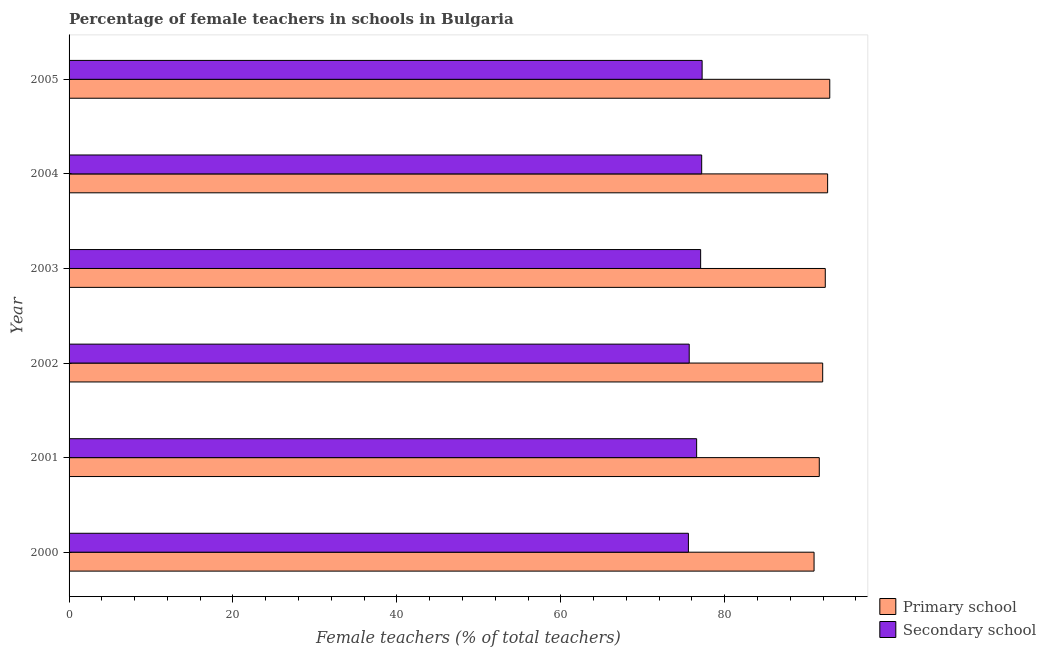How many different coloured bars are there?
Give a very brief answer. 2. How many bars are there on the 3rd tick from the top?
Give a very brief answer. 2. How many bars are there on the 4th tick from the bottom?
Offer a very short reply. 2. What is the percentage of female teachers in primary schools in 2000?
Your response must be concise. 90.91. Across all years, what is the maximum percentage of female teachers in primary schools?
Ensure brevity in your answer.  92.82. Across all years, what is the minimum percentage of female teachers in secondary schools?
Your answer should be compact. 75.57. In which year was the percentage of female teachers in secondary schools maximum?
Offer a very short reply. 2005. In which year was the percentage of female teachers in primary schools minimum?
Offer a terse response. 2000. What is the total percentage of female teachers in primary schools in the graph?
Make the answer very short. 552.06. What is the difference between the percentage of female teachers in secondary schools in 2002 and that in 2003?
Provide a succinct answer. -1.39. What is the difference between the percentage of female teachers in primary schools in 2000 and the percentage of female teachers in secondary schools in 2005?
Offer a terse response. 13.66. What is the average percentage of female teachers in secondary schools per year?
Give a very brief answer. 76.55. In the year 2005, what is the difference between the percentage of female teachers in secondary schools and percentage of female teachers in primary schools?
Offer a terse response. -15.57. In how many years, is the percentage of female teachers in secondary schools greater than 80 %?
Your response must be concise. 0. Is the percentage of female teachers in secondary schools in 2000 less than that in 2002?
Offer a very short reply. Yes. Is the difference between the percentage of female teachers in secondary schools in 2000 and 2003 greater than the difference between the percentage of female teachers in primary schools in 2000 and 2003?
Your answer should be compact. No. What is the difference between the highest and the second highest percentage of female teachers in primary schools?
Offer a terse response. 0.26. What is the difference between the highest and the lowest percentage of female teachers in secondary schools?
Offer a very short reply. 1.68. In how many years, is the percentage of female teachers in primary schools greater than the average percentage of female teachers in primary schools taken over all years?
Your response must be concise. 3. What does the 1st bar from the top in 2004 represents?
Provide a short and direct response. Secondary school. What does the 1st bar from the bottom in 2002 represents?
Offer a terse response. Primary school. How many bars are there?
Ensure brevity in your answer.  12. How many years are there in the graph?
Ensure brevity in your answer.  6. What is the difference between two consecutive major ticks on the X-axis?
Provide a succinct answer. 20. Are the values on the major ticks of X-axis written in scientific E-notation?
Keep it short and to the point. No. Does the graph contain any zero values?
Offer a terse response. No. Does the graph contain grids?
Provide a succinct answer. No. What is the title of the graph?
Give a very brief answer. Percentage of female teachers in schools in Bulgaria. What is the label or title of the X-axis?
Provide a short and direct response. Female teachers (% of total teachers). What is the label or title of the Y-axis?
Your answer should be compact. Year. What is the Female teachers (% of total teachers) in Primary school in 2000?
Offer a terse response. 90.91. What is the Female teachers (% of total teachers) of Secondary school in 2000?
Provide a succinct answer. 75.57. What is the Female teachers (% of total teachers) in Primary school in 2001?
Ensure brevity in your answer.  91.54. What is the Female teachers (% of total teachers) in Secondary school in 2001?
Your answer should be very brief. 76.58. What is the Female teachers (% of total teachers) in Primary school in 2002?
Ensure brevity in your answer.  91.96. What is the Female teachers (% of total teachers) of Secondary school in 2002?
Offer a terse response. 75.67. What is the Female teachers (% of total teachers) of Primary school in 2003?
Your response must be concise. 92.27. What is the Female teachers (% of total teachers) in Secondary school in 2003?
Keep it short and to the point. 77.06. What is the Female teachers (% of total teachers) of Primary school in 2004?
Offer a very short reply. 92.56. What is the Female teachers (% of total teachers) in Secondary school in 2004?
Make the answer very short. 77.19. What is the Female teachers (% of total teachers) in Primary school in 2005?
Provide a succinct answer. 92.82. What is the Female teachers (% of total teachers) of Secondary school in 2005?
Offer a terse response. 77.25. Across all years, what is the maximum Female teachers (% of total teachers) in Primary school?
Provide a short and direct response. 92.82. Across all years, what is the maximum Female teachers (% of total teachers) of Secondary school?
Offer a terse response. 77.25. Across all years, what is the minimum Female teachers (% of total teachers) of Primary school?
Provide a succinct answer. 90.91. Across all years, what is the minimum Female teachers (% of total teachers) of Secondary school?
Keep it short and to the point. 75.57. What is the total Female teachers (% of total teachers) in Primary school in the graph?
Provide a short and direct response. 552.06. What is the total Female teachers (% of total teachers) of Secondary school in the graph?
Your response must be concise. 459.32. What is the difference between the Female teachers (% of total teachers) of Primary school in 2000 and that in 2001?
Provide a short and direct response. -0.64. What is the difference between the Female teachers (% of total teachers) of Secondary school in 2000 and that in 2001?
Provide a succinct answer. -1.01. What is the difference between the Female teachers (% of total teachers) of Primary school in 2000 and that in 2002?
Make the answer very short. -1.05. What is the difference between the Female teachers (% of total teachers) of Secondary school in 2000 and that in 2002?
Your answer should be compact. -0.1. What is the difference between the Female teachers (% of total teachers) in Primary school in 2000 and that in 2003?
Offer a very short reply. -1.37. What is the difference between the Female teachers (% of total teachers) of Secondary school in 2000 and that in 2003?
Your response must be concise. -1.49. What is the difference between the Female teachers (% of total teachers) of Primary school in 2000 and that in 2004?
Keep it short and to the point. -1.65. What is the difference between the Female teachers (% of total teachers) in Secondary school in 2000 and that in 2004?
Provide a short and direct response. -1.62. What is the difference between the Female teachers (% of total teachers) of Primary school in 2000 and that in 2005?
Your answer should be very brief. -1.92. What is the difference between the Female teachers (% of total teachers) in Secondary school in 2000 and that in 2005?
Keep it short and to the point. -1.68. What is the difference between the Female teachers (% of total teachers) of Primary school in 2001 and that in 2002?
Your answer should be very brief. -0.42. What is the difference between the Female teachers (% of total teachers) of Secondary school in 2001 and that in 2002?
Offer a terse response. 0.91. What is the difference between the Female teachers (% of total teachers) in Primary school in 2001 and that in 2003?
Keep it short and to the point. -0.73. What is the difference between the Female teachers (% of total teachers) of Secondary school in 2001 and that in 2003?
Your response must be concise. -0.49. What is the difference between the Female teachers (% of total teachers) in Primary school in 2001 and that in 2004?
Ensure brevity in your answer.  -1.02. What is the difference between the Female teachers (% of total teachers) in Secondary school in 2001 and that in 2004?
Offer a terse response. -0.62. What is the difference between the Female teachers (% of total teachers) in Primary school in 2001 and that in 2005?
Provide a short and direct response. -1.28. What is the difference between the Female teachers (% of total teachers) in Secondary school in 2001 and that in 2005?
Provide a succinct answer. -0.67. What is the difference between the Female teachers (% of total teachers) in Primary school in 2002 and that in 2003?
Offer a very short reply. -0.32. What is the difference between the Female teachers (% of total teachers) in Secondary school in 2002 and that in 2003?
Keep it short and to the point. -1.39. What is the difference between the Female teachers (% of total teachers) of Primary school in 2002 and that in 2004?
Make the answer very short. -0.6. What is the difference between the Female teachers (% of total teachers) in Secondary school in 2002 and that in 2004?
Give a very brief answer. -1.52. What is the difference between the Female teachers (% of total teachers) in Primary school in 2002 and that in 2005?
Your response must be concise. -0.86. What is the difference between the Female teachers (% of total teachers) of Secondary school in 2002 and that in 2005?
Make the answer very short. -1.58. What is the difference between the Female teachers (% of total teachers) of Primary school in 2003 and that in 2004?
Your answer should be compact. -0.29. What is the difference between the Female teachers (% of total teachers) of Secondary school in 2003 and that in 2004?
Ensure brevity in your answer.  -0.13. What is the difference between the Female teachers (% of total teachers) of Primary school in 2003 and that in 2005?
Your answer should be compact. -0.55. What is the difference between the Female teachers (% of total teachers) in Secondary school in 2003 and that in 2005?
Provide a succinct answer. -0.18. What is the difference between the Female teachers (% of total teachers) of Primary school in 2004 and that in 2005?
Provide a succinct answer. -0.26. What is the difference between the Female teachers (% of total teachers) in Secondary school in 2004 and that in 2005?
Provide a short and direct response. -0.05. What is the difference between the Female teachers (% of total teachers) of Primary school in 2000 and the Female teachers (% of total teachers) of Secondary school in 2001?
Your answer should be compact. 14.33. What is the difference between the Female teachers (% of total teachers) in Primary school in 2000 and the Female teachers (% of total teachers) in Secondary school in 2002?
Offer a very short reply. 15.23. What is the difference between the Female teachers (% of total teachers) in Primary school in 2000 and the Female teachers (% of total teachers) in Secondary school in 2003?
Give a very brief answer. 13.84. What is the difference between the Female teachers (% of total teachers) in Primary school in 2000 and the Female teachers (% of total teachers) in Secondary school in 2004?
Keep it short and to the point. 13.71. What is the difference between the Female teachers (% of total teachers) in Primary school in 2000 and the Female teachers (% of total teachers) in Secondary school in 2005?
Offer a terse response. 13.66. What is the difference between the Female teachers (% of total teachers) in Primary school in 2001 and the Female teachers (% of total teachers) in Secondary school in 2002?
Offer a very short reply. 15.87. What is the difference between the Female teachers (% of total teachers) of Primary school in 2001 and the Female teachers (% of total teachers) of Secondary school in 2003?
Offer a very short reply. 14.48. What is the difference between the Female teachers (% of total teachers) in Primary school in 2001 and the Female teachers (% of total teachers) in Secondary school in 2004?
Make the answer very short. 14.35. What is the difference between the Female teachers (% of total teachers) of Primary school in 2001 and the Female teachers (% of total teachers) of Secondary school in 2005?
Provide a succinct answer. 14.29. What is the difference between the Female teachers (% of total teachers) in Primary school in 2002 and the Female teachers (% of total teachers) in Secondary school in 2003?
Offer a very short reply. 14.89. What is the difference between the Female teachers (% of total teachers) in Primary school in 2002 and the Female teachers (% of total teachers) in Secondary school in 2004?
Your answer should be compact. 14.76. What is the difference between the Female teachers (% of total teachers) of Primary school in 2002 and the Female teachers (% of total teachers) of Secondary school in 2005?
Your answer should be very brief. 14.71. What is the difference between the Female teachers (% of total teachers) of Primary school in 2003 and the Female teachers (% of total teachers) of Secondary school in 2004?
Keep it short and to the point. 15.08. What is the difference between the Female teachers (% of total teachers) of Primary school in 2003 and the Female teachers (% of total teachers) of Secondary school in 2005?
Provide a succinct answer. 15.03. What is the difference between the Female teachers (% of total teachers) of Primary school in 2004 and the Female teachers (% of total teachers) of Secondary school in 2005?
Make the answer very short. 15.31. What is the average Female teachers (% of total teachers) of Primary school per year?
Provide a succinct answer. 92.01. What is the average Female teachers (% of total teachers) in Secondary school per year?
Make the answer very short. 76.55. In the year 2000, what is the difference between the Female teachers (% of total teachers) of Primary school and Female teachers (% of total teachers) of Secondary school?
Offer a terse response. 15.33. In the year 2001, what is the difference between the Female teachers (% of total teachers) in Primary school and Female teachers (% of total teachers) in Secondary school?
Provide a succinct answer. 14.96. In the year 2002, what is the difference between the Female teachers (% of total teachers) of Primary school and Female teachers (% of total teachers) of Secondary school?
Offer a terse response. 16.29. In the year 2003, what is the difference between the Female teachers (% of total teachers) in Primary school and Female teachers (% of total teachers) in Secondary school?
Your answer should be very brief. 15.21. In the year 2004, what is the difference between the Female teachers (% of total teachers) of Primary school and Female teachers (% of total teachers) of Secondary school?
Provide a succinct answer. 15.37. In the year 2005, what is the difference between the Female teachers (% of total teachers) in Primary school and Female teachers (% of total teachers) in Secondary school?
Your answer should be compact. 15.57. What is the ratio of the Female teachers (% of total teachers) of Primary school in 2000 to that in 2001?
Provide a short and direct response. 0.99. What is the ratio of the Female teachers (% of total teachers) of Secondary school in 2000 to that in 2001?
Make the answer very short. 0.99. What is the ratio of the Female teachers (% of total teachers) of Primary school in 2000 to that in 2002?
Your answer should be compact. 0.99. What is the ratio of the Female teachers (% of total teachers) in Primary school in 2000 to that in 2003?
Your response must be concise. 0.99. What is the ratio of the Female teachers (% of total teachers) in Secondary school in 2000 to that in 2003?
Keep it short and to the point. 0.98. What is the ratio of the Female teachers (% of total teachers) in Primary school in 2000 to that in 2004?
Give a very brief answer. 0.98. What is the ratio of the Female teachers (% of total teachers) in Primary school in 2000 to that in 2005?
Provide a succinct answer. 0.98. What is the ratio of the Female teachers (% of total teachers) of Secondary school in 2000 to that in 2005?
Your answer should be compact. 0.98. What is the ratio of the Female teachers (% of total teachers) of Primary school in 2001 to that in 2002?
Your response must be concise. 1. What is the ratio of the Female teachers (% of total teachers) in Primary school in 2001 to that in 2005?
Offer a very short reply. 0.99. What is the ratio of the Female teachers (% of total teachers) in Primary school in 2002 to that in 2003?
Offer a very short reply. 1. What is the ratio of the Female teachers (% of total teachers) of Secondary school in 2002 to that in 2003?
Ensure brevity in your answer.  0.98. What is the ratio of the Female teachers (% of total teachers) of Primary school in 2002 to that in 2004?
Ensure brevity in your answer.  0.99. What is the ratio of the Female teachers (% of total teachers) in Secondary school in 2002 to that in 2004?
Give a very brief answer. 0.98. What is the ratio of the Female teachers (% of total teachers) in Primary school in 2002 to that in 2005?
Offer a very short reply. 0.99. What is the ratio of the Female teachers (% of total teachers) in Secondary school in 2002 to that in 2005?
Ensure brevity in your answer.  0.98. What is the ratio of the Female teachers (% of total teachers) in Secondary school in 2003 to that in 2004?
Your answer should be very brief. 1. What is the ratio of the Female teachers (% of total teachers) in Secondary school in 2003 to that in 2005?
Your answer should be very brief. 1. What is the ratio of the Female teachers (% of total teachers) of Primary school in 2004 to that in 2005?
Your answer should be compact. 1. What is the ratio of the Female teachers (% of total teachers) in Secondary school in 2004 to that in 2005?
Offer a terse response. 1. What is the difference between the highest and the second highest Female teachers (% of total teachers) in Primary school?
Provide a short and direct response. 0.26. What is the difference between the highest and the second highest Female teachers (% of total teachers) in Secondary school?
Offer a very short reply. 0.05. What is the difference between the highest and the lowest Female teachers (% of total teachers) of Primary school?
Your response must be concise. 1.92. What is the difference between the highest and the lowest Female teachers (% of total teachers) of Secondary school?
Provide a succinct answer. 1.68. 